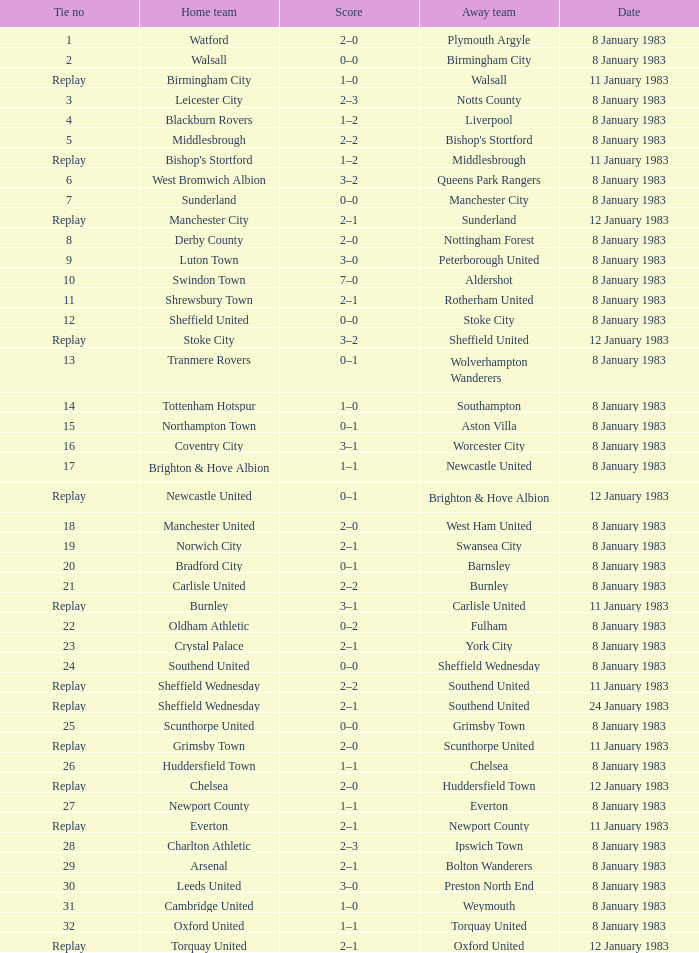What was the end result of the match in which leeds united hosted the game? 3–0. 